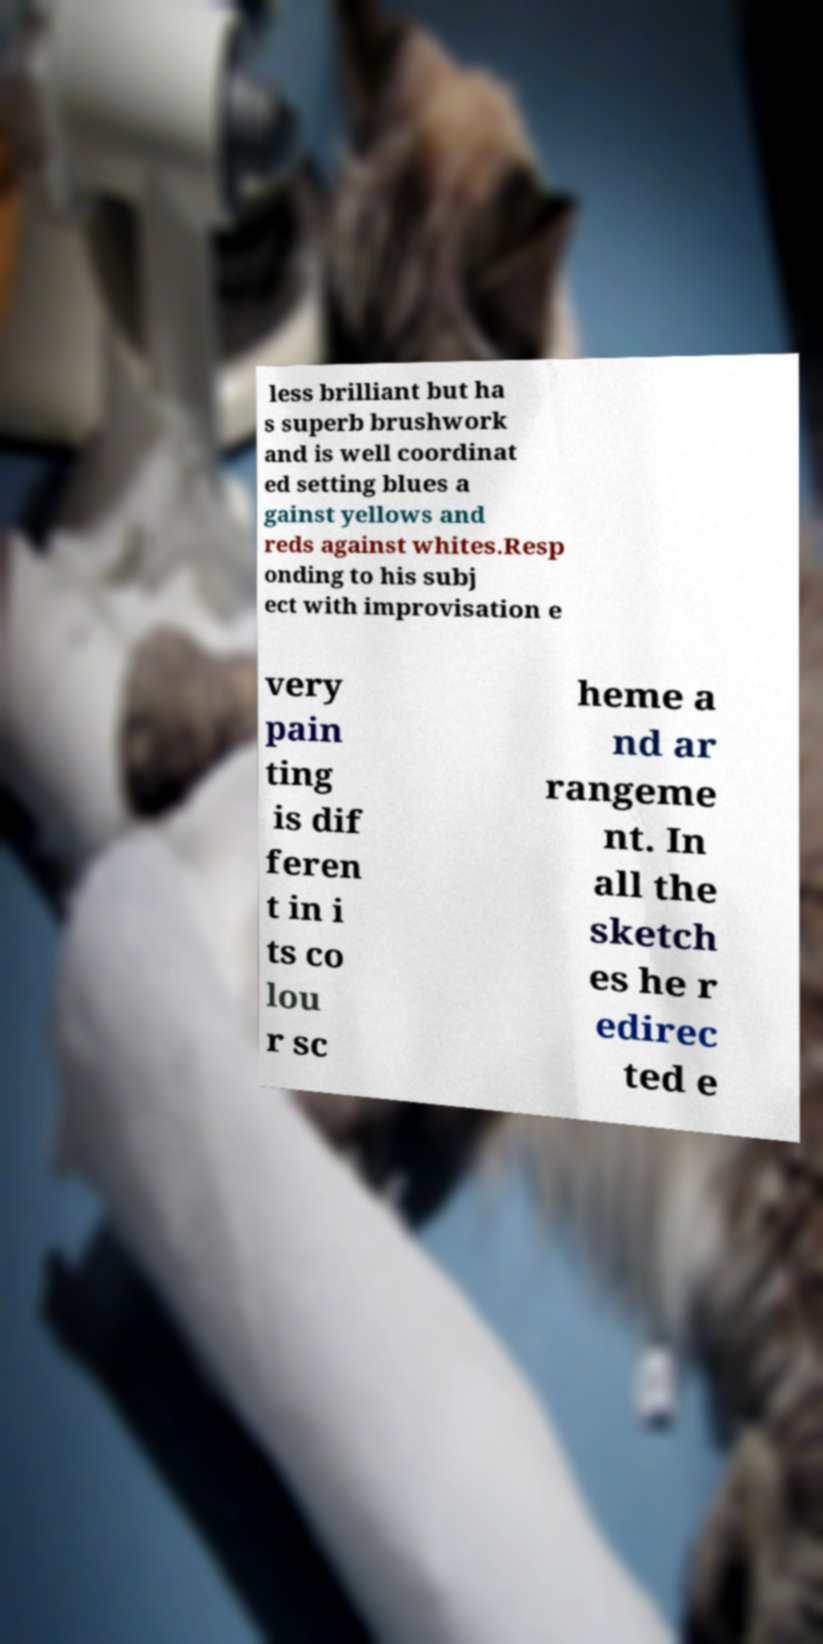Please read and relay the text visible in this image. What does it say? less brilliant but ha s superb brushwork and is well coordinat ed setting blues a gainst yellows and reds against whites.Resp onding to his subj ect with improvisation e very pain ting is dif feren t in i ts co lou r sc heme a nd ar rangeme nt. In all the sketch es he r edirec ted e 